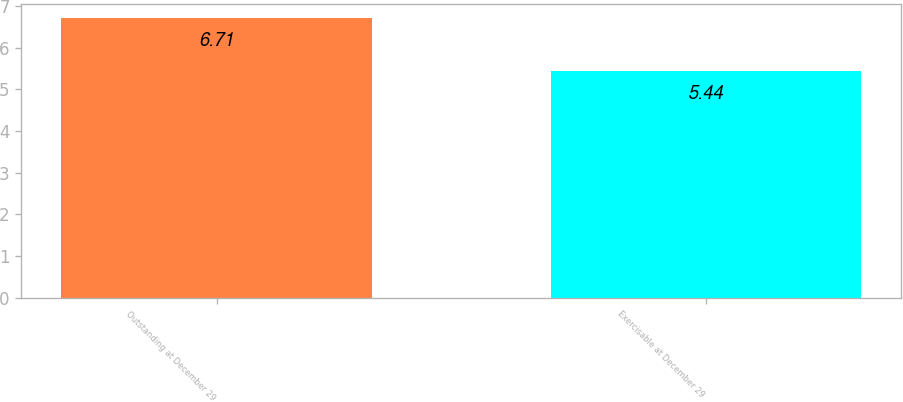<chart> <loc_0><loc_0><loc_500><loc_500><bar_chart><fcel>Outstanding at December 29<fcel>Exercisable at December 29<nl><fcel>6.71<fcel>5.44<nl></chart> 